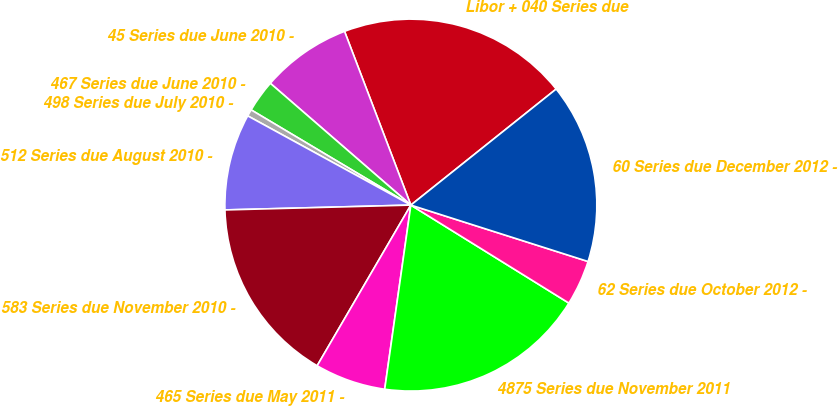<chart> <loc_0><loc_0><loc_500><loc_500><pie_chart><fcel>Libor + 040 Series due<fcel>45 Series due June 2010 -<fcel>467 Series due June 2010 -<fcel>498 Series due July 2010 -<fcel>512 Series due August 2010 -<fcel>583 Series due November 2010 -<fcel>465 Series due May 2011 -<fcel>4875 Series due November 2011<fcel>62 Series due October 2012 -<fcel>60 Series due December 2012 -<nl><fcel>20.08%<fcel>7.83%<fcel>2.81%<fcel>0.59%<fcel>8.38%<fcel>16.18%<fcel>6.16%<fcel>18.41%<fcel>3.93%<fcel>15.63%<nl></chart> 